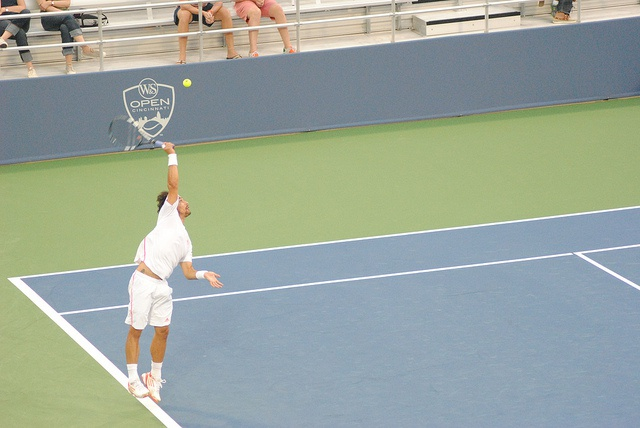Describe the objects in this image and their specific colors. I can see people in salmon, white, darkgray, and tan tones, bench in salmon, darkgray, ivory, and lightgray tones, people in salmon, tan, and gray tones, people in salmon, tan, and brown tones, and people in salmon, black, gray, tan, and darkgray tones in this image. 